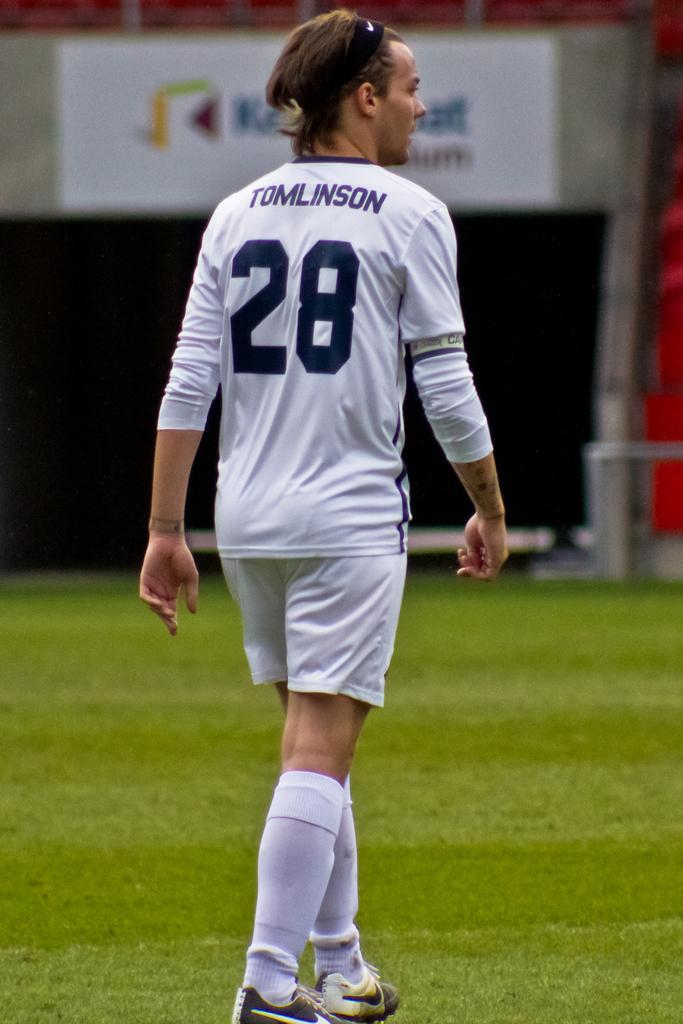Provide a one-sentence caption for the provided image. A sportsperson with the number 28 on their shirt. 